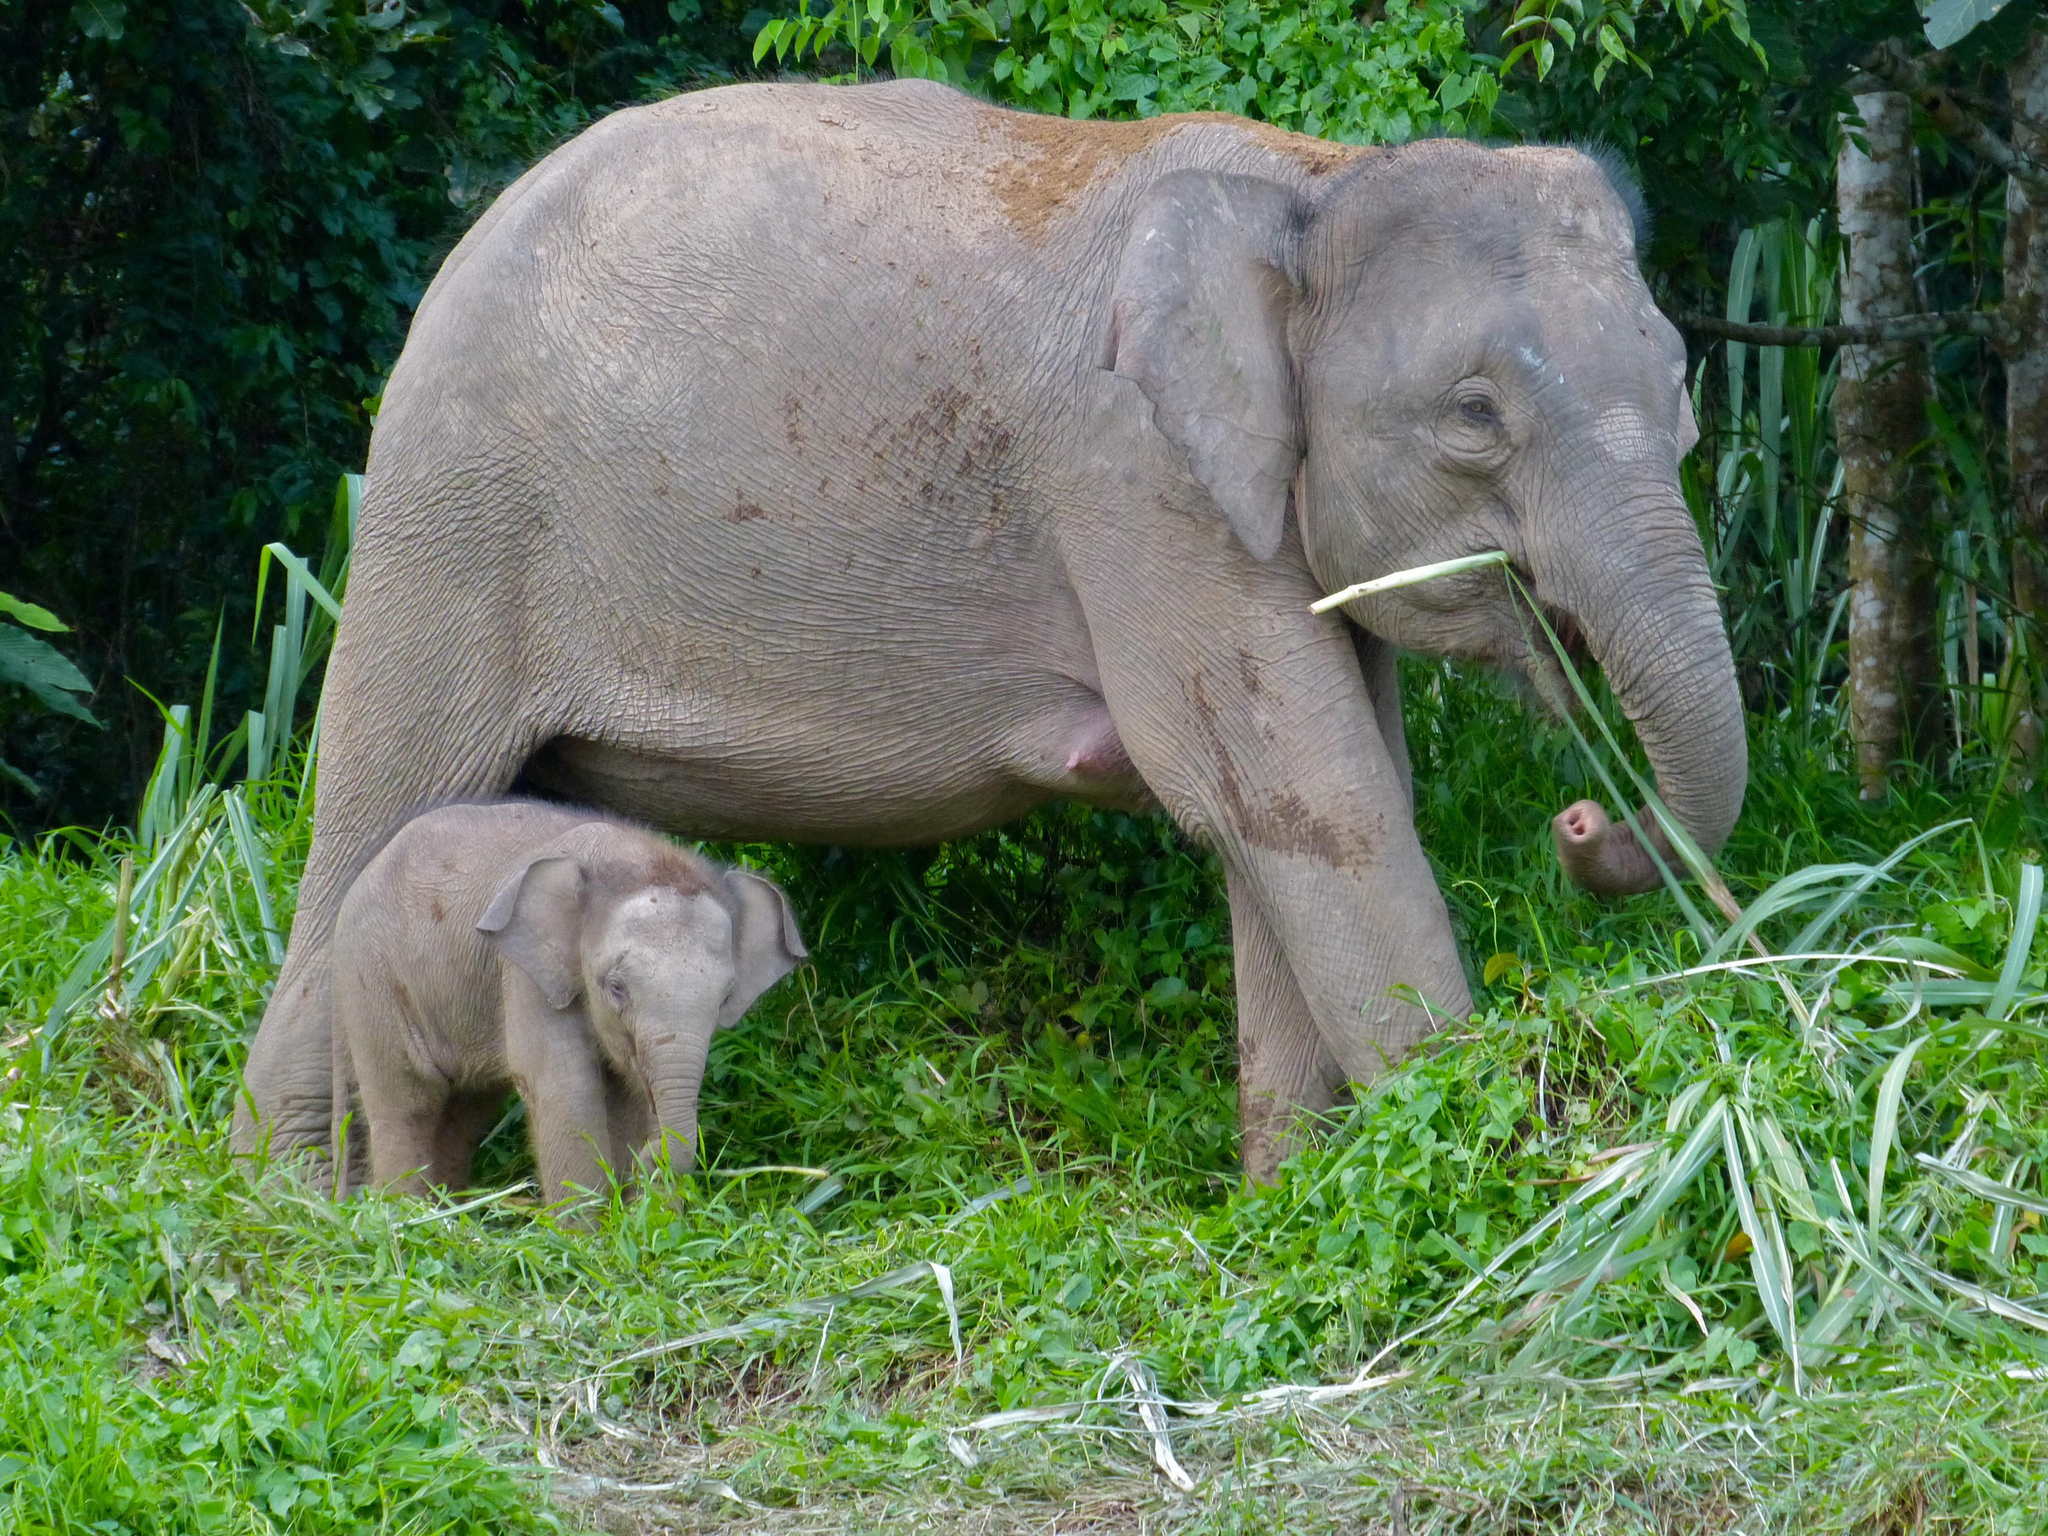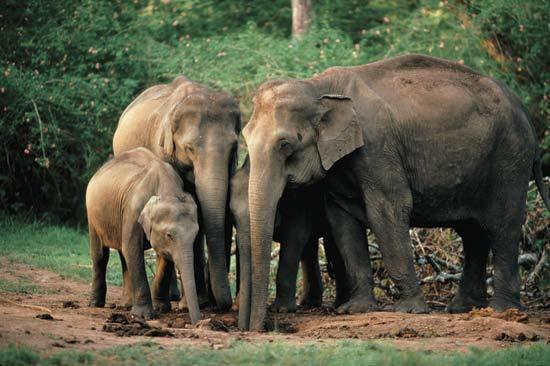The first image is the image on the left, the second image is the image on the right. Examine the images to the left and right. Is the description "The right image contains a single elephant with large tusks." accurate? Answer yes or no. No. The first image is the image on the left, the second image is the image on the right. Examine the images to the left and right. Is the description "The right image contains only one elephant." accurate? Answer yes or no. No. 